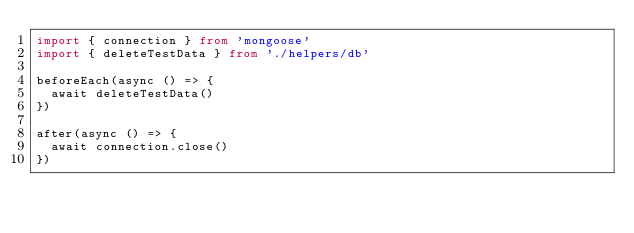<code> <loc_0><loc_0><loc_500><loc_500><_TypeScript_>import { connection } from 'mongoose'
import { deleteTestData } from './helpers/db'

beforeEach(async () => {
  await deleteTestData()
})

after(async () => {
  await connection.close()
})
</code> 